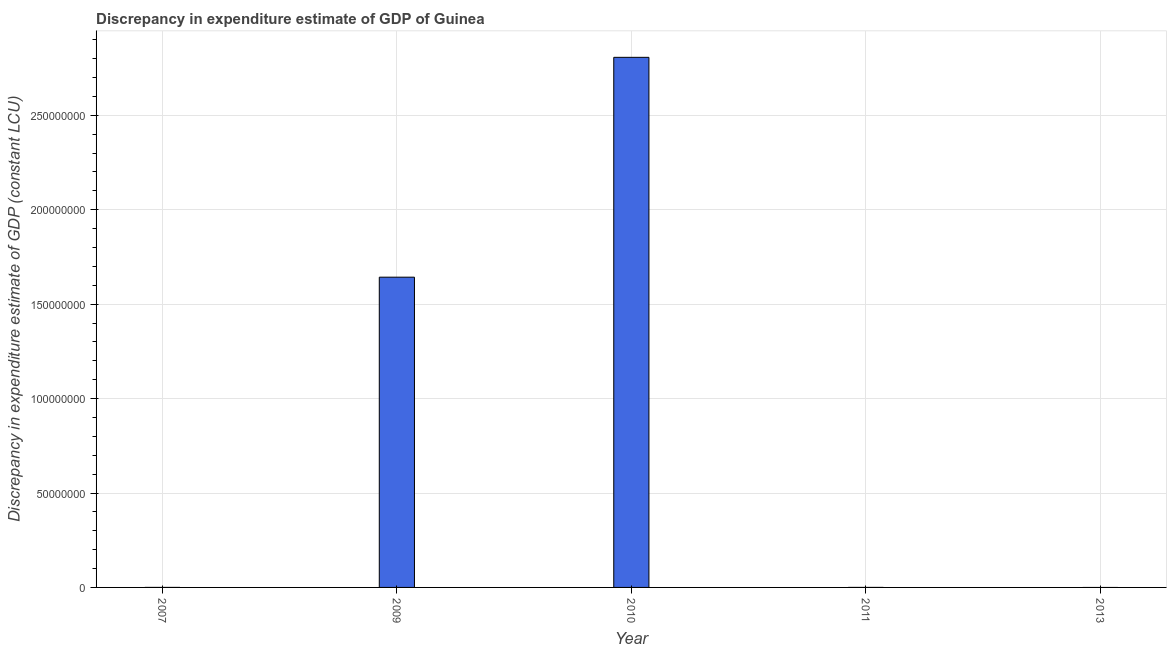Does the graph contain any zero values?
Give a very brief answer. Yes. Does the graph contain grids?
Provide a succinct answer. Yes. What is the title of the graph?
Your response must be concise. Discrepancy in expenditure estimate of GDP of Guinea. What is the label or title of the X-axis?
Provide a short and direct response. Year. What is the label or title of the Y-axis?
Give a very brief answer. Discrepancy in expenditure estimate of GDP (constant LCU). What is the discrepancy in expenditure estimate of gdp in 2013?
Keep it short and to the point. 0. Across all years, what is the maximum discrepancy in expenditure estimate of gdp?
Keep it short and to the point. 2.81e+08. Across all years, what is the minimum discrepancy in expenditure estimate of gdp?
Your answer should be compact. 0. In which year was the discrepancy in expenditure estimate of gdp maximum?
Make the answer very short. 2010. What is the sum of the discrepancy in expenditure estimate of gdp?
Give a very brief answer. 4.45e+08. What is the difference between the discrepancy in expenditure estimate of gdp in 2010 and 2011?
Provide a succinct answer. 2.81e+08. What is the average discrepancy in expenditure estimate of gdp per year?
Give a very brief answer. 8.90e+07. In how many years, is the discrepancy in expenditure estimate of gdp greater than 210000000 LCU?
Provide a succinct answer. 1. What is the ratio of the discrepancy in expenditure estimate of gdp in 2007 to that in 2011?
Provide a short and direct response. 1. Is the difference between the discrepancy in expenditure estimate of gdp in 2007 and 2010 greater than the difference between any two years?
Your answer should be very brief. No. What is the difference between the highest and the second highest discrepancy in expenditure estimate of gdp?
Your answer should be compact. 1.16e+08. What is the difference between the highest and the lowest discrepancy in expenditure estimate of gdp?
Give a very brief answer. 2.81e+08. How many bars are there?
Offer a terse response. 4. Are all the bars in the graph horizontal?
Provide a short and direct response. No. What is the Discrepancy in expenditure estimate of GDP (constant LCU) of 2009?
Provide a short and direct response. 1.64e+08. What is the Discrepancy in expenditure estimate of GDP (constant LCU) in 2010?
Make the answer very short. 2.81e+08. What is the Discrepancy in expenditure estimate of GDP (constant LCU) in 2011?
Your answer should be very brief. 100. What is the difference between the Discrepancy in expenditure estimate of GDP (constant LCU) in 2007 and 2009?
Ensure brevity in your answer.  -1.64e+08. What is the difference between the Discrepancy in expenditure estimate of GDP (constant LCU) in 2007 and 2010?
Your answer should be compact. -2.81e+08. What is the difference between the Discrepancy in expenditure estimate of GDP (constant LCU) in 2007 and 2011?
Your answer should be compact. 0. What is the difference between the Discrepancy in expenditure estimate of GDP (constant LCU) in 2009 and 2010?
Your answer should be very brief. -1.16e+08. What is the difference between the Discrepancy in expenditure estimate of GDP (constant LCU) in 2009 and 2011?
Ensure brevity in your answer.  1.64e+08. What is the difference between the Discrepancy in expenditure estimate of GDP (constant LCU) in 2010 and 2011?
Ensure brevity in your answer.  2.81e+08. What is the ratio of the Discrepancy in expenditure estimate of GDP (constant LCU) in 2007 to that in 2010?
Offer a very short reply. 0. What is the ratio of the Discrepancy in expenditure estimate of GDP (constant LCU) in 2007 to that in 2011?
Provide a succinct answer. 1. What is the ratio of the Discrepancy in expenditure estimate of GDP (constant LCU) in 2009 to that in 2010?
Your response must be concise. 0.58. What is the ratio of the Discrepancy in expenditure estimate of GDP (constant LCU) in 2009 to that in 2011?
Your answer should be very brief. 1.64e+06. What is the ratio of the Discrepancy in expenditure estimate of GDP (constant LCU) in 2010 to that in 2011?
Offer a very short reply. 2.81e+06. 